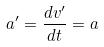Convert formula to latex. <formula><loc_0><loc_0><loc_500><loc_500>a ^ { \prime } = \frac { d v ^ { \prime } } { d t } = a</formula> 